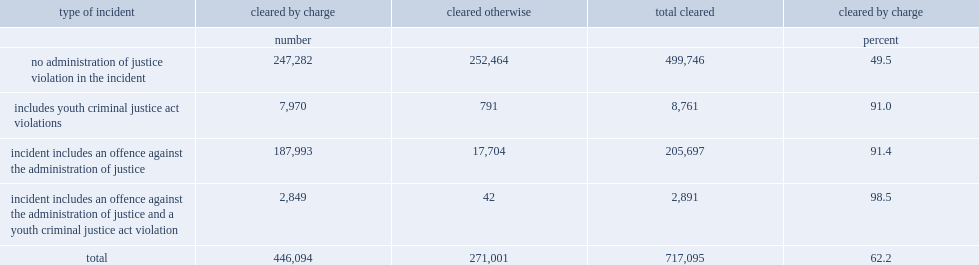In 2014,what is the percentage of incidents includes an offence against the administration of justice cleared by charge? 91.4. In 2014,what is the percentage of incidents that did not include administration of justice offences cleared by charge? 49.5. 